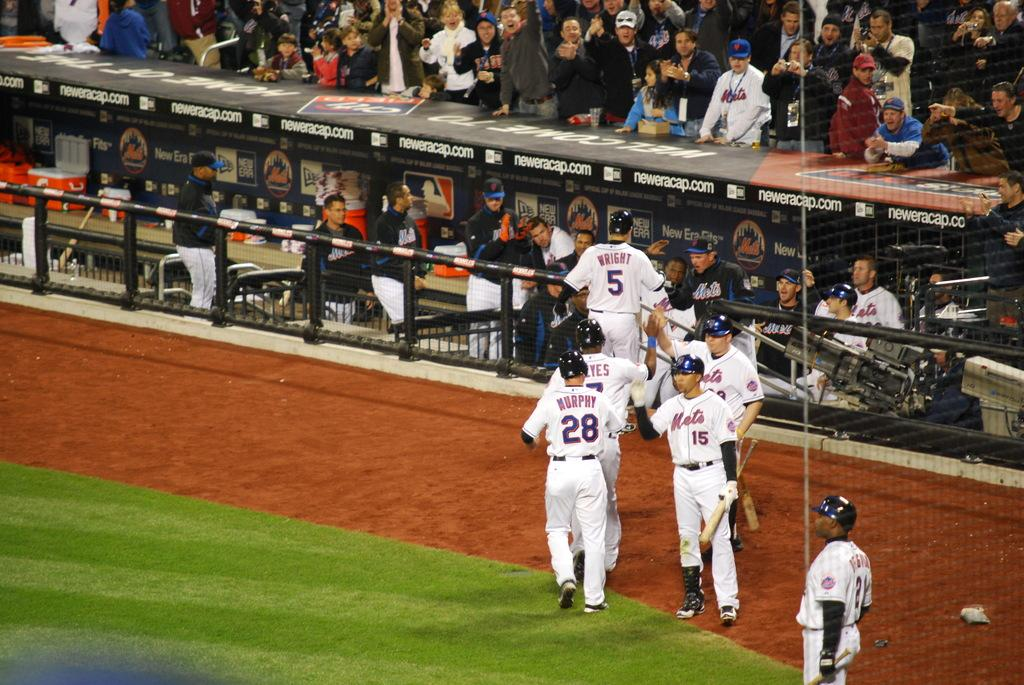<image>
Give a short and clear explanation of the subsequent image. A ball player named Murphy exchanges greetings with his teammates. 